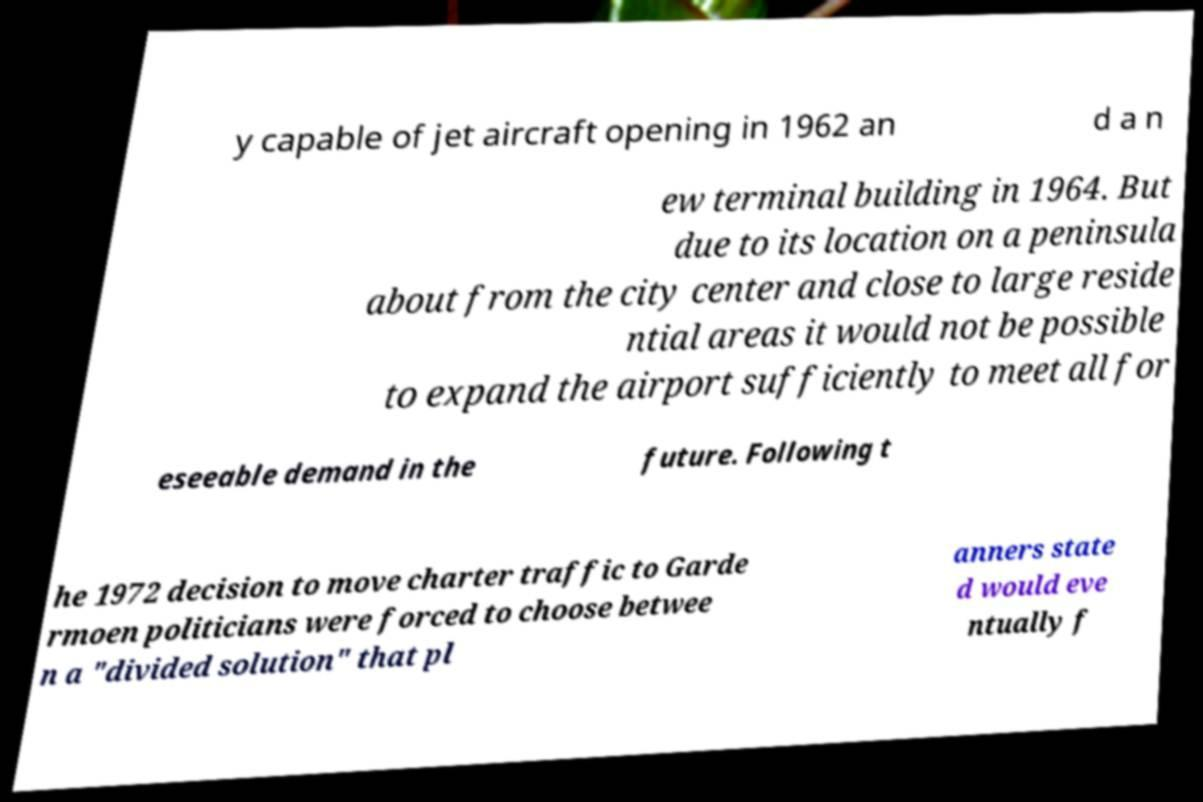Please read and relay the text visible in this image. What does it say? y capable of jet aircraft opening in 1962 an d a n ew terminal building in 1964. But due to its location on a peninsula about from the city center and close to large reside ntial areas it would not be possible to expand the airport sufficiently to meet all for eseeable demand in the future. Following t he 1972 decision to move charter traffic to Garde rmoen politicians were forced to choose betwee n a "divided solution" that pl anners state d would eve ntually f 